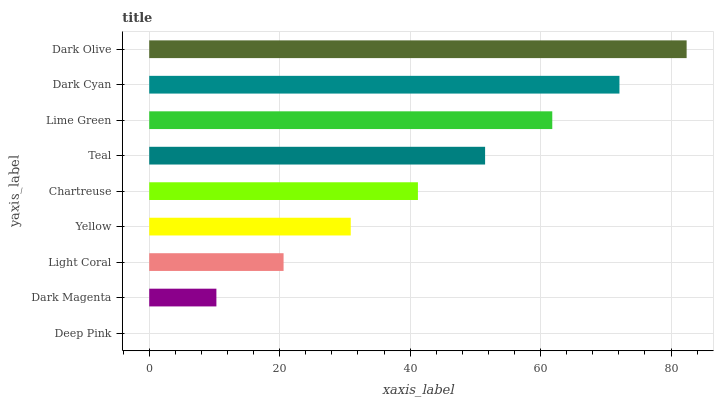Is Deep Pink the minimum?
Answer yes or no. Yes. Is Dark Olive the maximum?
Answer yes or no. Yes. Is Dark Magenta the minimum?
Answer yes or no. No. Is Dark Magenta the maximum?
Answer yes or no. No. Is Dark Magenta greater than Deep Pink?
Answer yes or no. Yes. Is Deep Pink less than Dark Magenta?
Answer yes or no. Yes. Is Deep Pink greater than Dark Magenta?
Answer yes or no. No. Is Dark Magenta less than Deep Pink?
Answer yes or no. No. Is Chartreuse the high median?
Answer yes or no. Yes. Is Chartreuse the low median?
Answer yes or no. Yes. Is Yellow the high median?
Answer yes or no. No. Is Light Coral the low median?
Answer yes or no. No. 